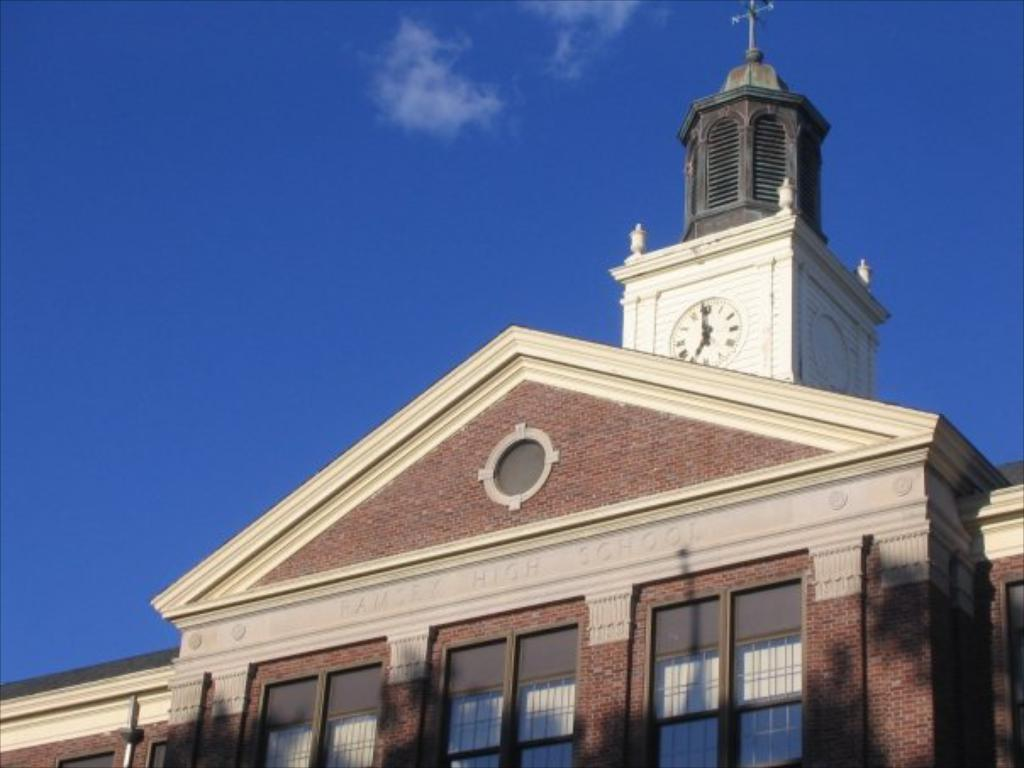What type of structure is in the image? There is a building in the image. What material is used for the walls of the building? The building has brick walls. What type of windows are on the building? The building has glass windows. What architectural feature is present on the building? The building has pillars with a clock. What is visible at the top of the image? The sky is visible at the top of the image. How many toes can be seen in the image? There are no toes visible in the image. 